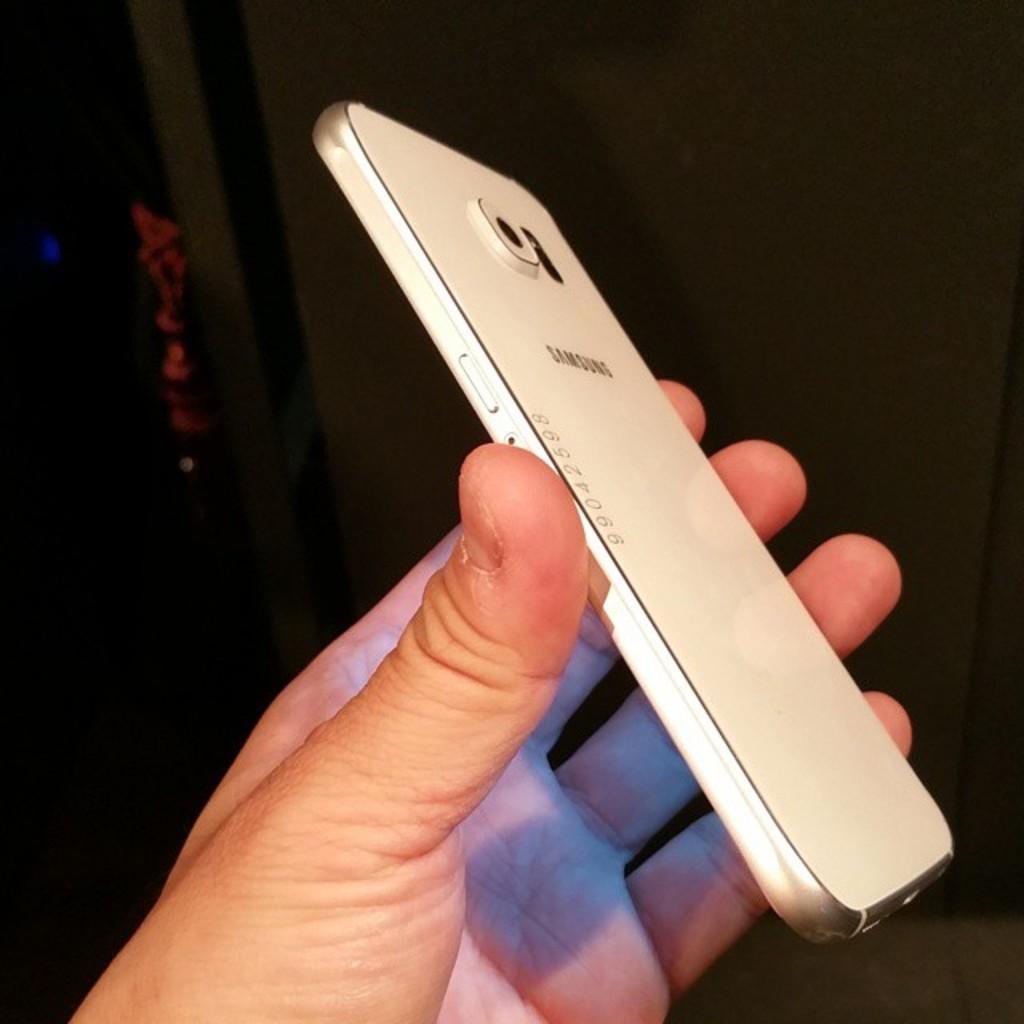In one or two sentences, can you explain what this image depicts? There is a mobile phone,a person is holding the phone in his hand and it is of white color. 